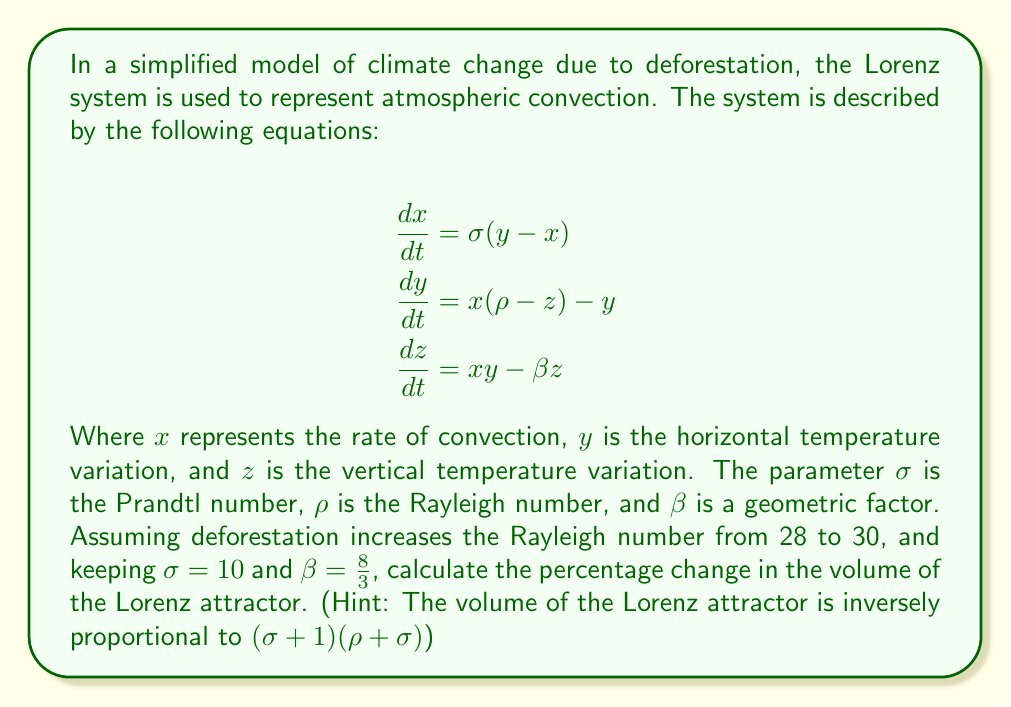What is the answer to this math problem? To solve this problem, we'll follow these steps:

1) First, let's recall the formula for the volume of the Lorenz attractor:
   
   $$V \propto \frac{1}{(\sigma + 1)(\rho + \sigma)}$$

2) We'll calculate the volume for the initial conditions ($\rho = 28$) and the new conditions ($\rho = 30$).

3) For the initial conditions:
   $\sigma = 10$, $\rho = 28$
   
   $$V_1 \propto \frac{1}{(10 + 1)(28 + 10)} = \frac{1}{11 \times 38} = \frac{1}{418}$$

4) For the new conditions after deforestation:
   $\sigma = 10$, $\rho = 30$
   
   $$V_2 \propto \frac{1}{(10 + 1)(30 + 10)} = \frac{1}{11 \times 40} = \frac{1}{440}$$

5) To calculate the percentage change, we use the formula:

   $$\text{Percentage Change} = \frac{V_2 - V_1}{V_1} \times 100\%$$

6) Substituting our values:

   $$\text{Percentage Change} = \frac{\frac{1}{440} - \frac{1}{418}}{\frac{1}{418}} \times 100\%$$

7) Simplifying:

   $$\text{Percentage Change} = \left(\frac{418}{440} - 1\right) \times 100\% = -5.00\%$$

Therefore, the volume of the Lorenz attractor decreases by approximately 5.00% due to the increase in the Rayleigh number caused by deforestation.
Answer: -5.00% 